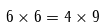<formula> <loc_0><loc_0><loc_500><loc_500>6 \times 6 = 4 \times 9</formula> 